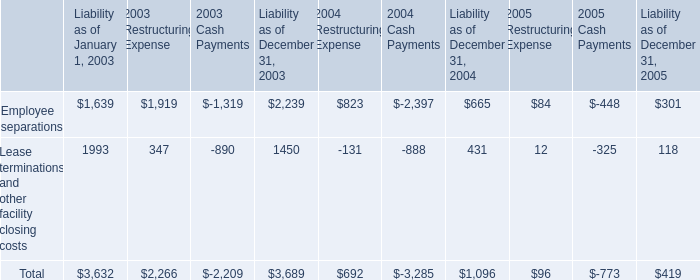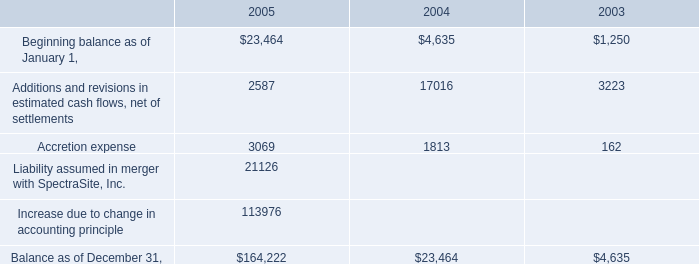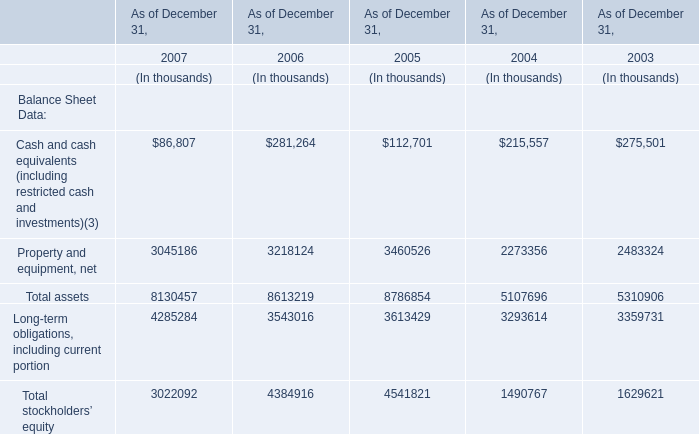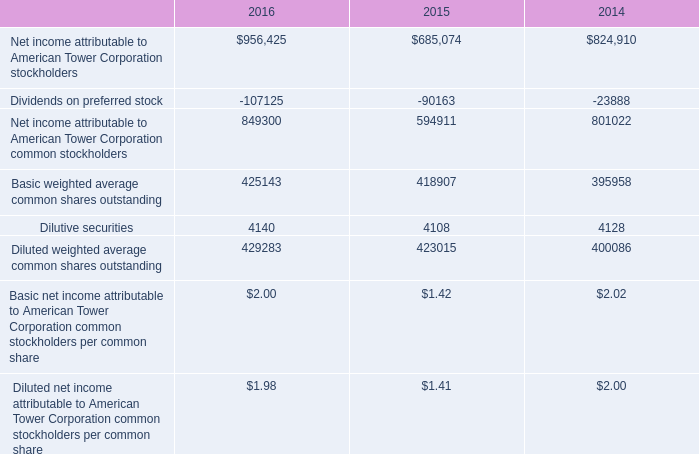what was the average write-off of construction-in-progress impairment charges from 2003 to 2005 in millions 
Computations: (((2.3 + 4.6) + 9.2) / 3)
Answer: 5.36667. 